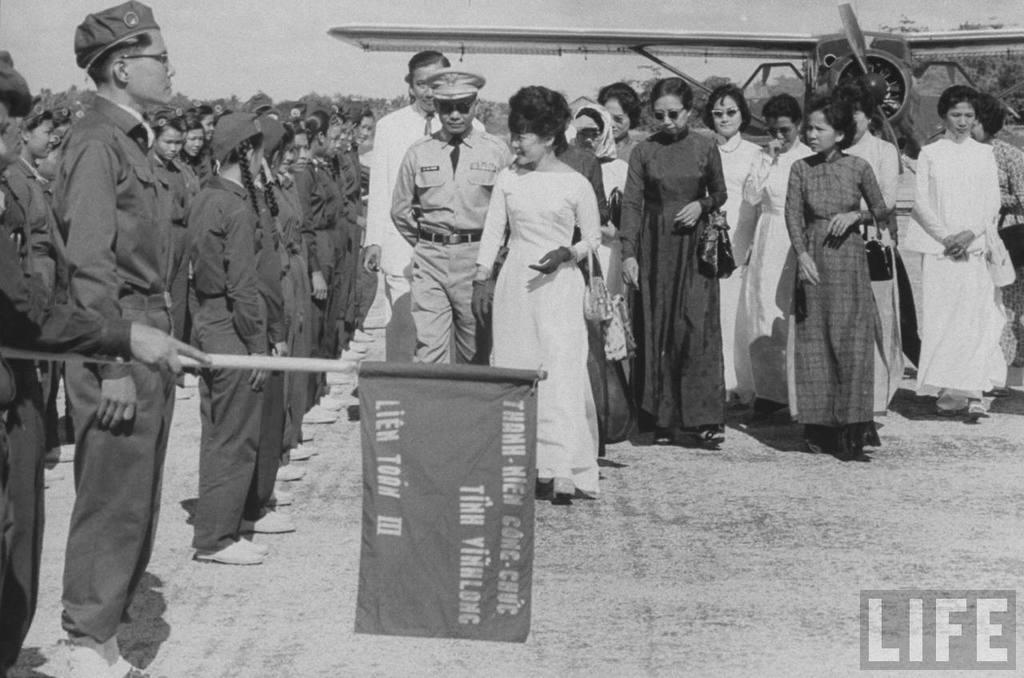Provide a one-sentence caption for the provided image. An old photo taken by Life magazine shows a man holding a flag that reads Lien Toon III. 